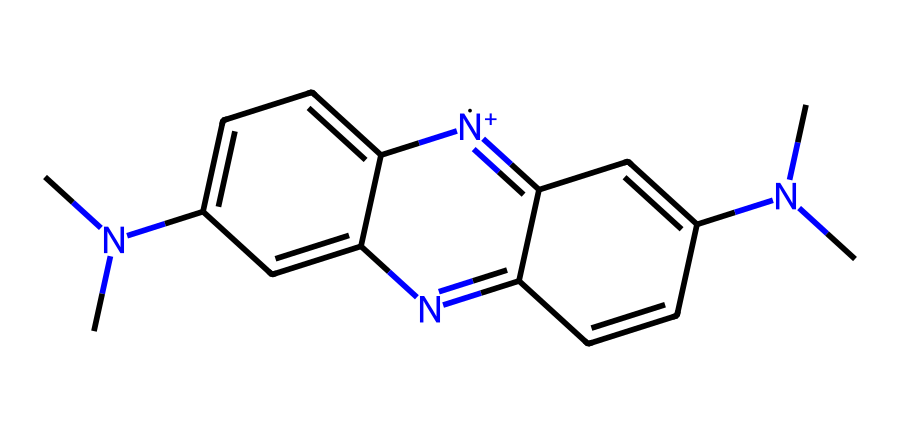What is the molecular formula of acridine orange? To find the molecular formula, count all the atoms represented in the SMILES notation: C=12, H=12, N=4. Putting this together gives us C12H12N4.
Answer: C12H12N4 How many nitrogen atoms are present in the structure? By analyzing the SMILES, we can see that there are 4 nitrogen symbols (N), which indicates there are 4 nitrogen atoms in the structure.
Answer: 4 What type of chemical structure is acridine orange classified as? Acridine orange is classified as a phenothiazine derivative, which is a type of synthetic organic compound often used in dyes and fluorescent agents. The presence of aromatic rings and nitrogen in the structure indicates this classification.
Answer: phenothiazine Which part of the molecule contributes to its fluorescence? The polycyclic aromatic structure, particularly the acridine ring system, allows for the conjugated system that can absorb light and re-emit it as fluorescence. This region provides the necessary electronic transitions for fluorescence.
Answer: acridine ring Is acridine orange a cationic or anionic dye? The structure contains positively charged nitrogen atoms (noted by [n+]), which indicates that acridine orange operates as a cationic dye. This positive charge facilitates binding to negatively charged cellular components, enhancing its staining properties.
Answer: cationic What is the significance of the dimethylamino groups in this dye? The dimethylamino groups (–N(CH3)2) enhance the solubility and binding affinity of acridine orange to nucleic acids within cells, improving its efficacy as a fluorescent marker in microscopy.
Answer: solubility and binding affinity 